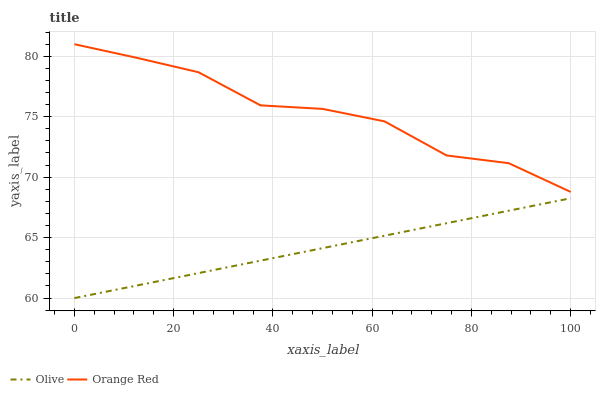Does Olive have the minimum area under the curve?
Answer yes or no. Yes. Does Orange Red have the maximum area under the curve?
Answer yes or no. Yes. Does Orange Red have the minimum area under the curve?
Answer yes or no. No. Is Olive the smoothest?
Answer yes or no. Yes. Is Orange Red the roughest?
Answer yes or no. Yes. Is Orange Red the smoothest?
Answer yes or no. No. Does Orange Red have the lowest value?
Answer yes or no. No. Does Orange Red have the highest value?
Answer yes or no. Yes. Is Olive less than Orange Red?
Answer yes or no. Yes. Is Orange Red greater than Olive?
Answer yes or no. Yes. Does Olive intersect Orange Red?
Answer yes or no. No. 